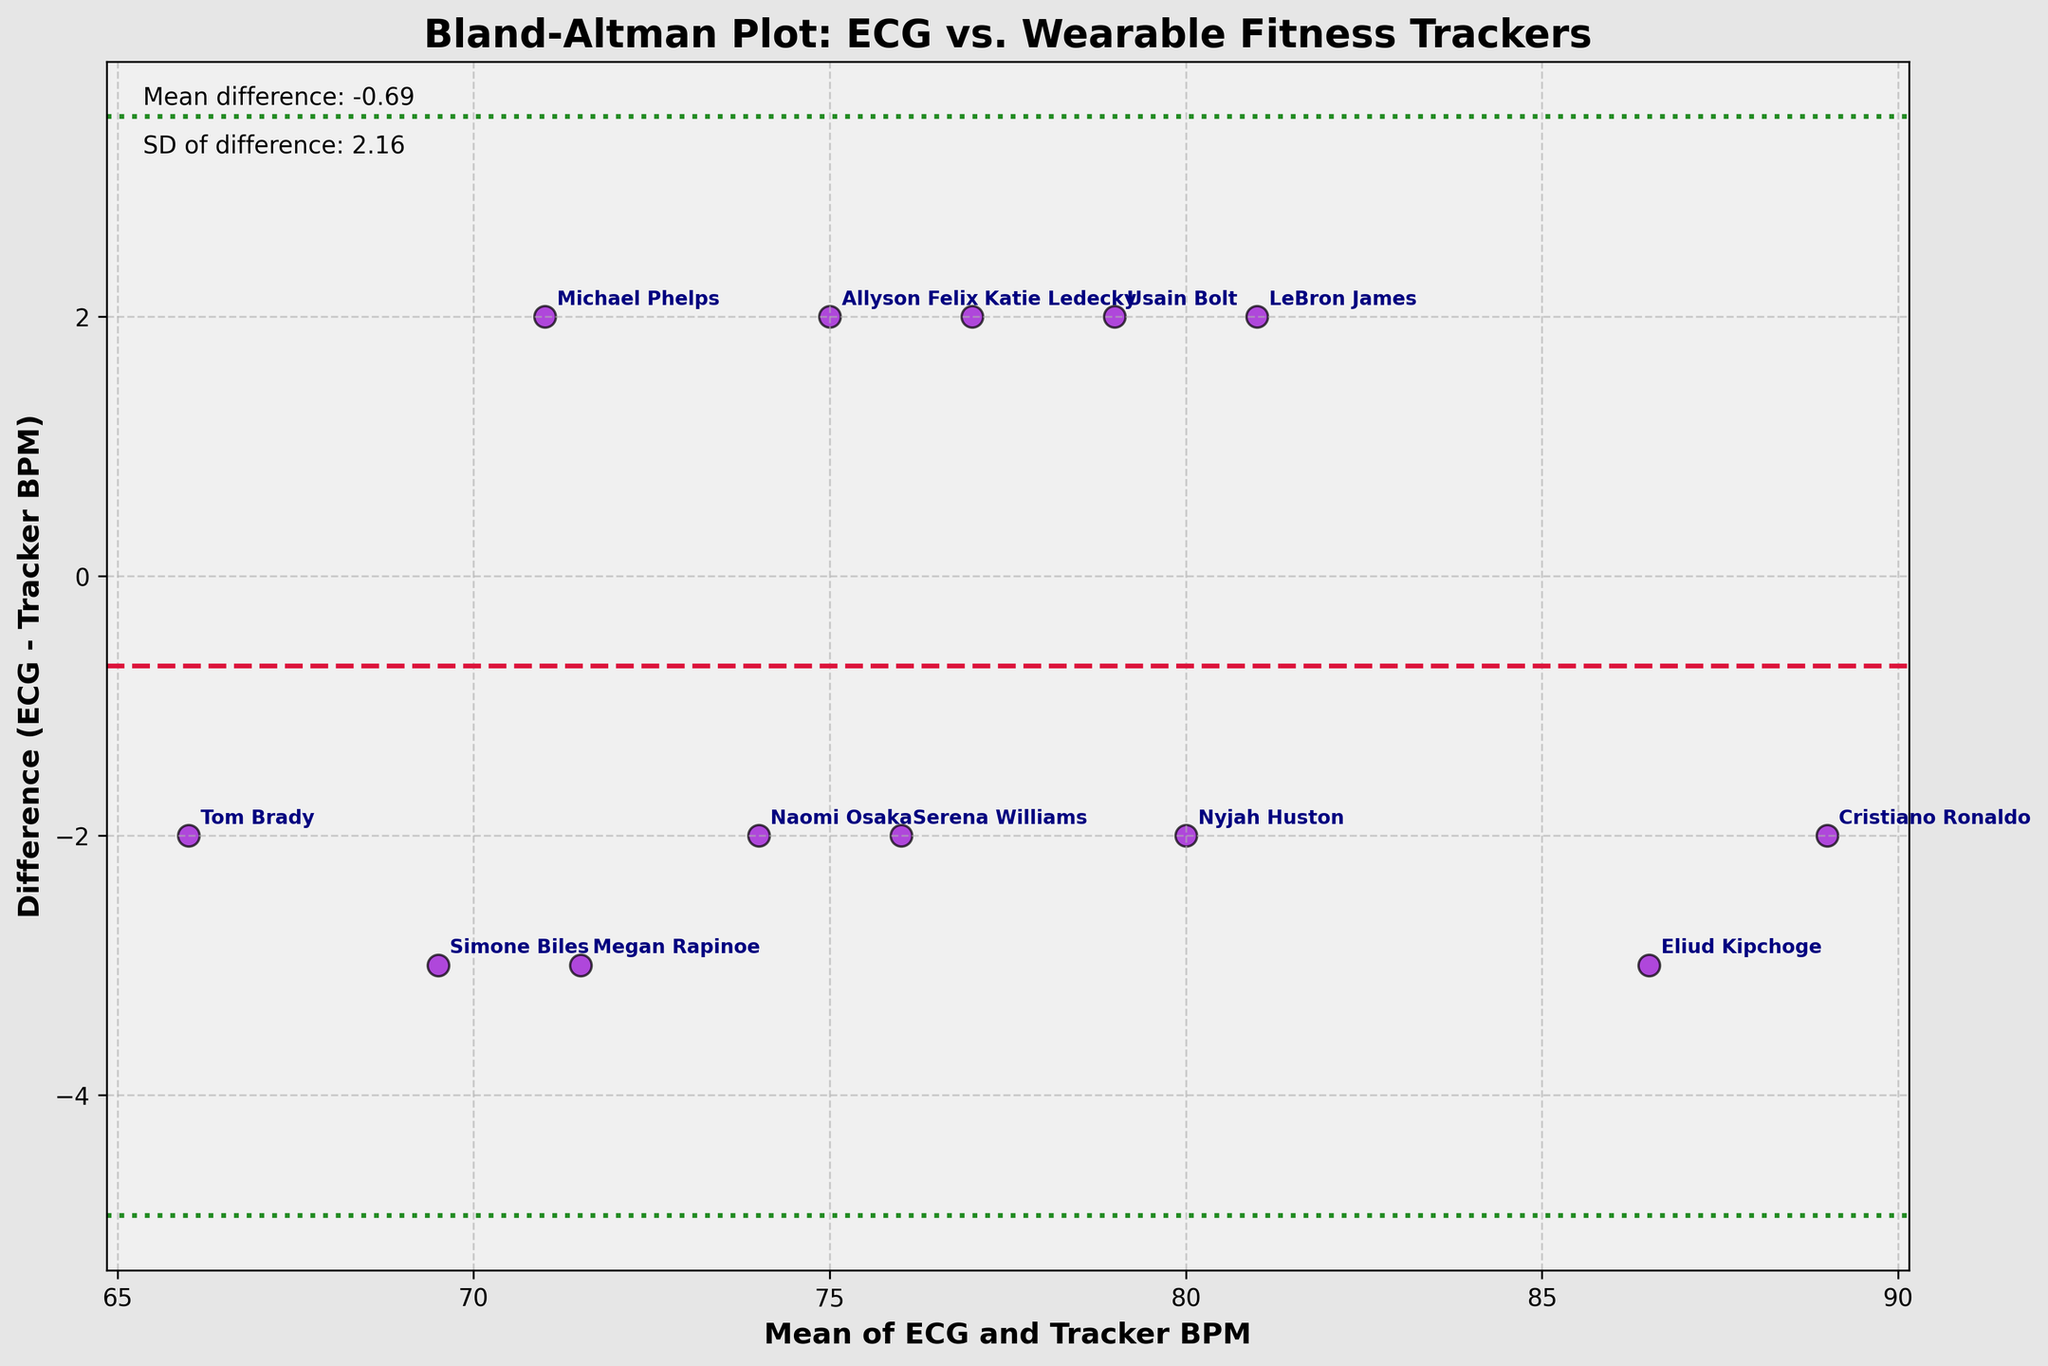What is the title of the plot? The title appears at the top of the figure and summarizes the main subject of the plot, which is "Bland-Altman Plot: ECG vs. Wearable Fitness Trackers".
Answer: Bland-Altman Plot: ECG vs. Wearable Fitness Trackers How many athletes' data points are displayed in the plot? The plot has individual data points marked by scatter points, corresponding to the 13 different athletes listed in the dataset. Each athlete's name is annotated near their respective data points.
Answer: 13 What color represents the data points in the plot? The data points are symbolized using darkviolet with a black edge around each dot, as observed in the figure.
Answer: Darkviolet What is the mean difference between the ECG and wearable fitness tracker measurements? The mean difference (md) is visually indicated by a horizontal dashed line in crimson, with an annotation close to the top left corner of the plot displaying the mean difference's value.
Answer: -0.38 Which athlete has the largest positive difference between ECG and tracker measurements? Observing the annotations near each data point, Eliud Kipchoge appears to have the highest positive difference, shown by the position significantly above the zero-difference line.
Answer: Eliud Kipchoge What are the upper and lower limits of agreement in the plot? The limits of agreement are shown by two horizontal dotted lines, which are the mean difference ± 1.96 times the standard deviation. These values are annotated near the top left corner of the plot as well. If the mean is -0.38 and the standard deviation is 2.2, the upper limit is approximately 3.95, and the lower limit is approximately -4.71.
Answer: Upper: 3.95, Lower: -4.71 How do Serena Williams’ heart rate measurements compare between the ECG and the fitness tracker? Serena Williams' data point is annotated and located slightly above the zero-difference line, indicating that her heart rate reading from the wearable tracker is slightly higher than that from the ECG.
Answer: Tracker is slightly higher Which device’s data point is closest to the mean difference line? Observing the scatter points and their annotations near the mean difference line, Katie Ledecky's data seems to be very close to this line.
Answer: Withings ScanWatch (Katie Ledecky) How variable are the differences between ECG and tracker measurements among athletes? The variation is indicated by the spread of points around the mean difference line. The visual ranges from-4.71 to 3.95 around the mean difference, reflecting a relatively wide spread of differences.
Answer: Relatively wide What does it signify if a data point lies outside the limits of agreement? Points outside the limits of agreement (±1.96 SD) indicate outliers where the tracker’s measurement significantly deviates from the ECG, suggesting potential inconsistency or error in the wearable device.
Answer: Potential inconsistency/error 